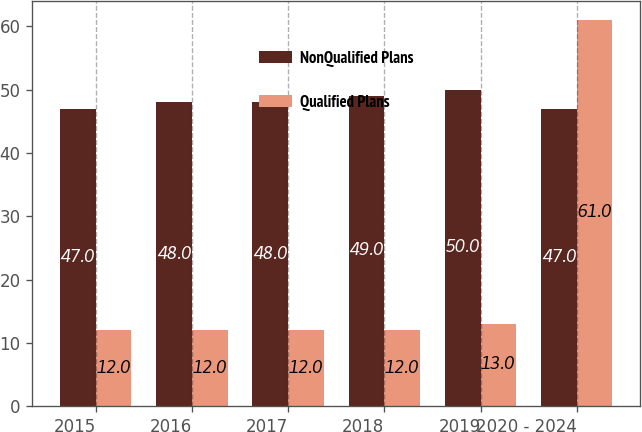Convert chart. <chart><loc_0><loc_0><loc_500><loc_500><stacked_bar_chart><ecel><fcel>2015<fcel>2016<fcel>2017<fcel>2018<fcel>2019<fcel>2020 - 2024<nl><fcel>NonQualified Plans<fcel>47<fcel>48<fcel>48<fcel>49<fcel>50<fcel>47<nl><fcel>Qualified Plans<fcel>12<fcel>12<fcel>12<fcel>12<fcel>13<fcel>61<nl></chart> 